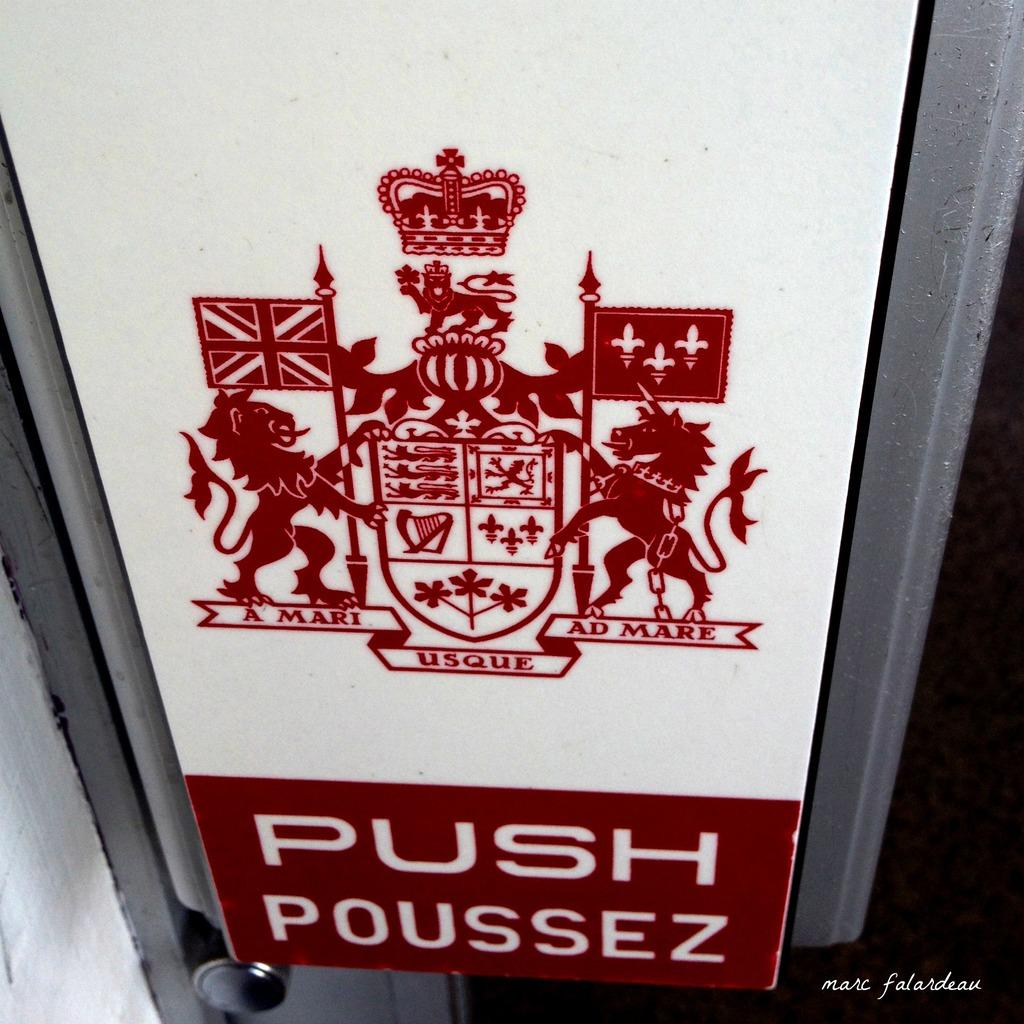<image>
Summarize the visual content of the image. A sign with a coat of arms at the top and the words, push poussez at the bottom. 